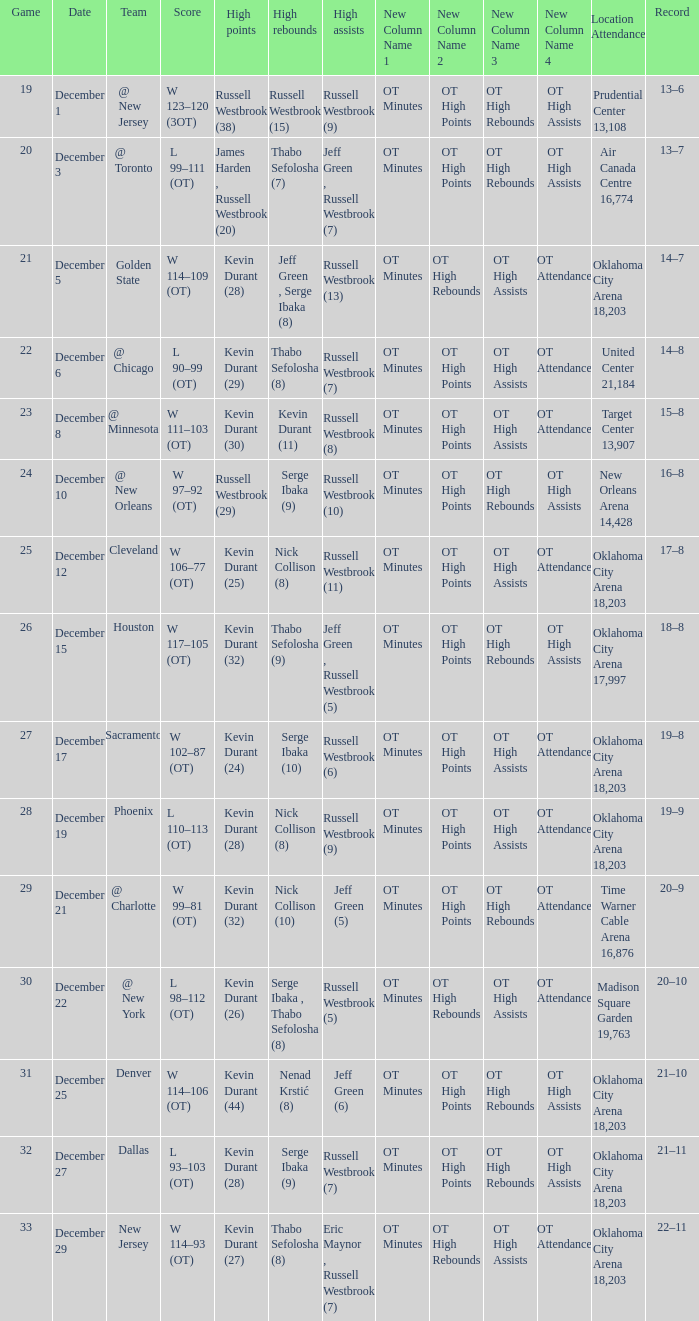What was the record on December 27? 21–11. 